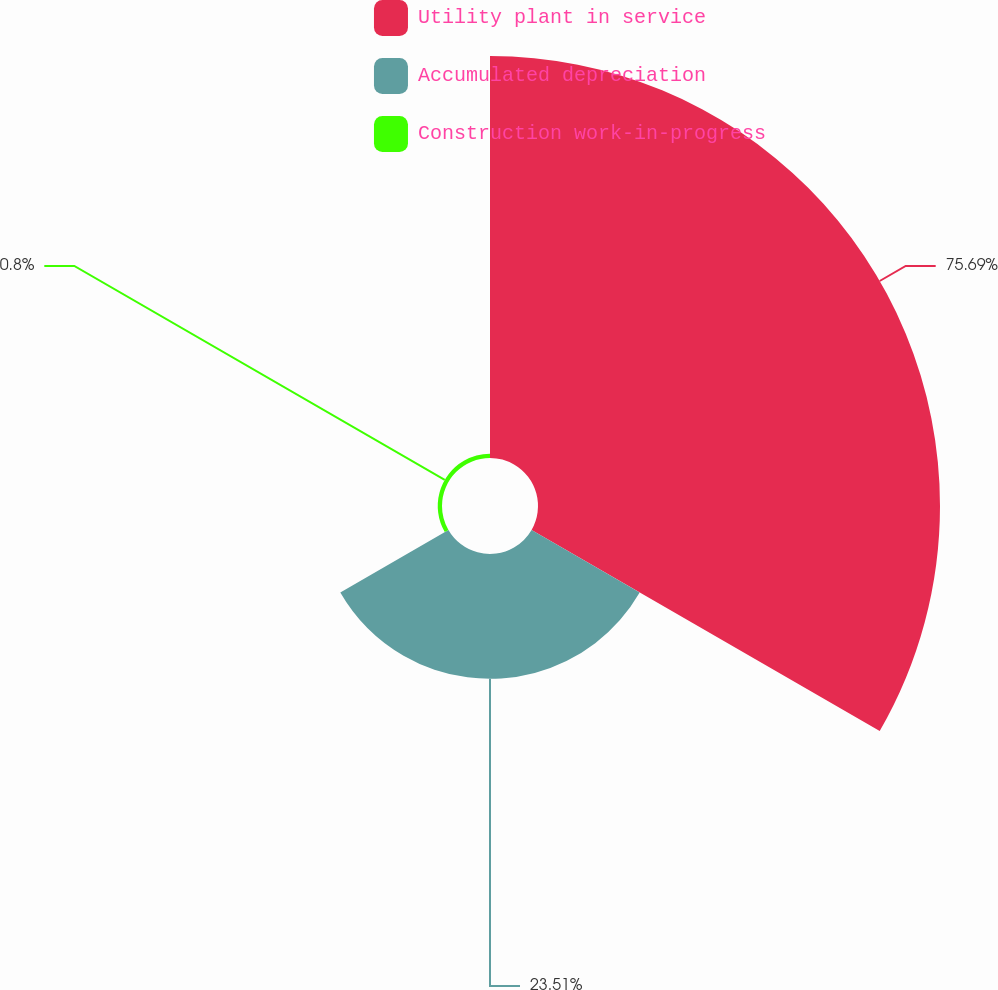Convert chart. <chart><loc_0><loc_0><loc_500><loc_500><pie_chart><fcel>Utility plant in service<fcel>Accumulated depreciation<fcel>Construction work-in-progress<nl><fcel>75.7%<fcel>23.51%<fcel>0.8%<nl></chart> 